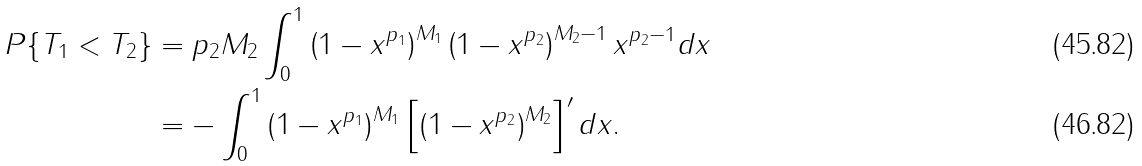<formula> <loc_0><loc_0><loc_500><loc_500>P \{ T _ { 1 } < T _ { 2 } \} & = p _ { 2 } M _ { 2 } \int _ { 0 } ^ { 1 } \left ( 1 - x ^ { p _ { 1 } } \right ) ^ { M _ { 1 } } \left ( 1 - x ^ { p _ { 2 } } \right ) ^ { M _ { 2 } - 1 } x ^ { p _ { 2 } - 1 } d x \\ & = - \int _ { 0 } ^ { 1 } \left ( 1 - x ^ { p _ { 1 } } \right ) ^ { M _ { 1 } } \left [ \left ( 1 - x ^ { p _ { 2 } } \right ) ^ { M _ { 2 } } \right ] ^ { \prime } d x .</formula> 